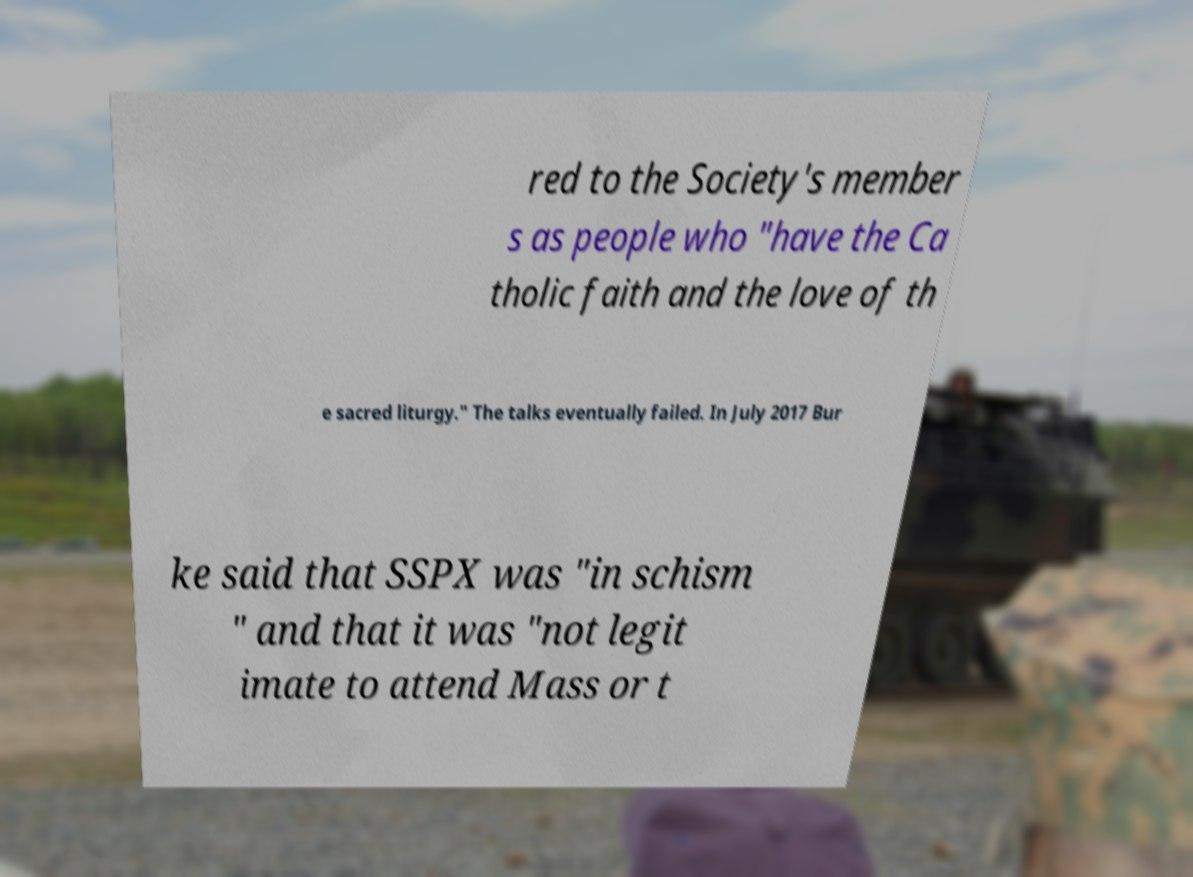Could you extract and type out the text from this image? red to the Society's member s as people who "have the Ca tholic faith and the love of th e sacred liturgy." The talks eventually failed. In July 2017 Bur ke said that SSPX was "in schism " and that it was "not legit imate to attend Mass or t 